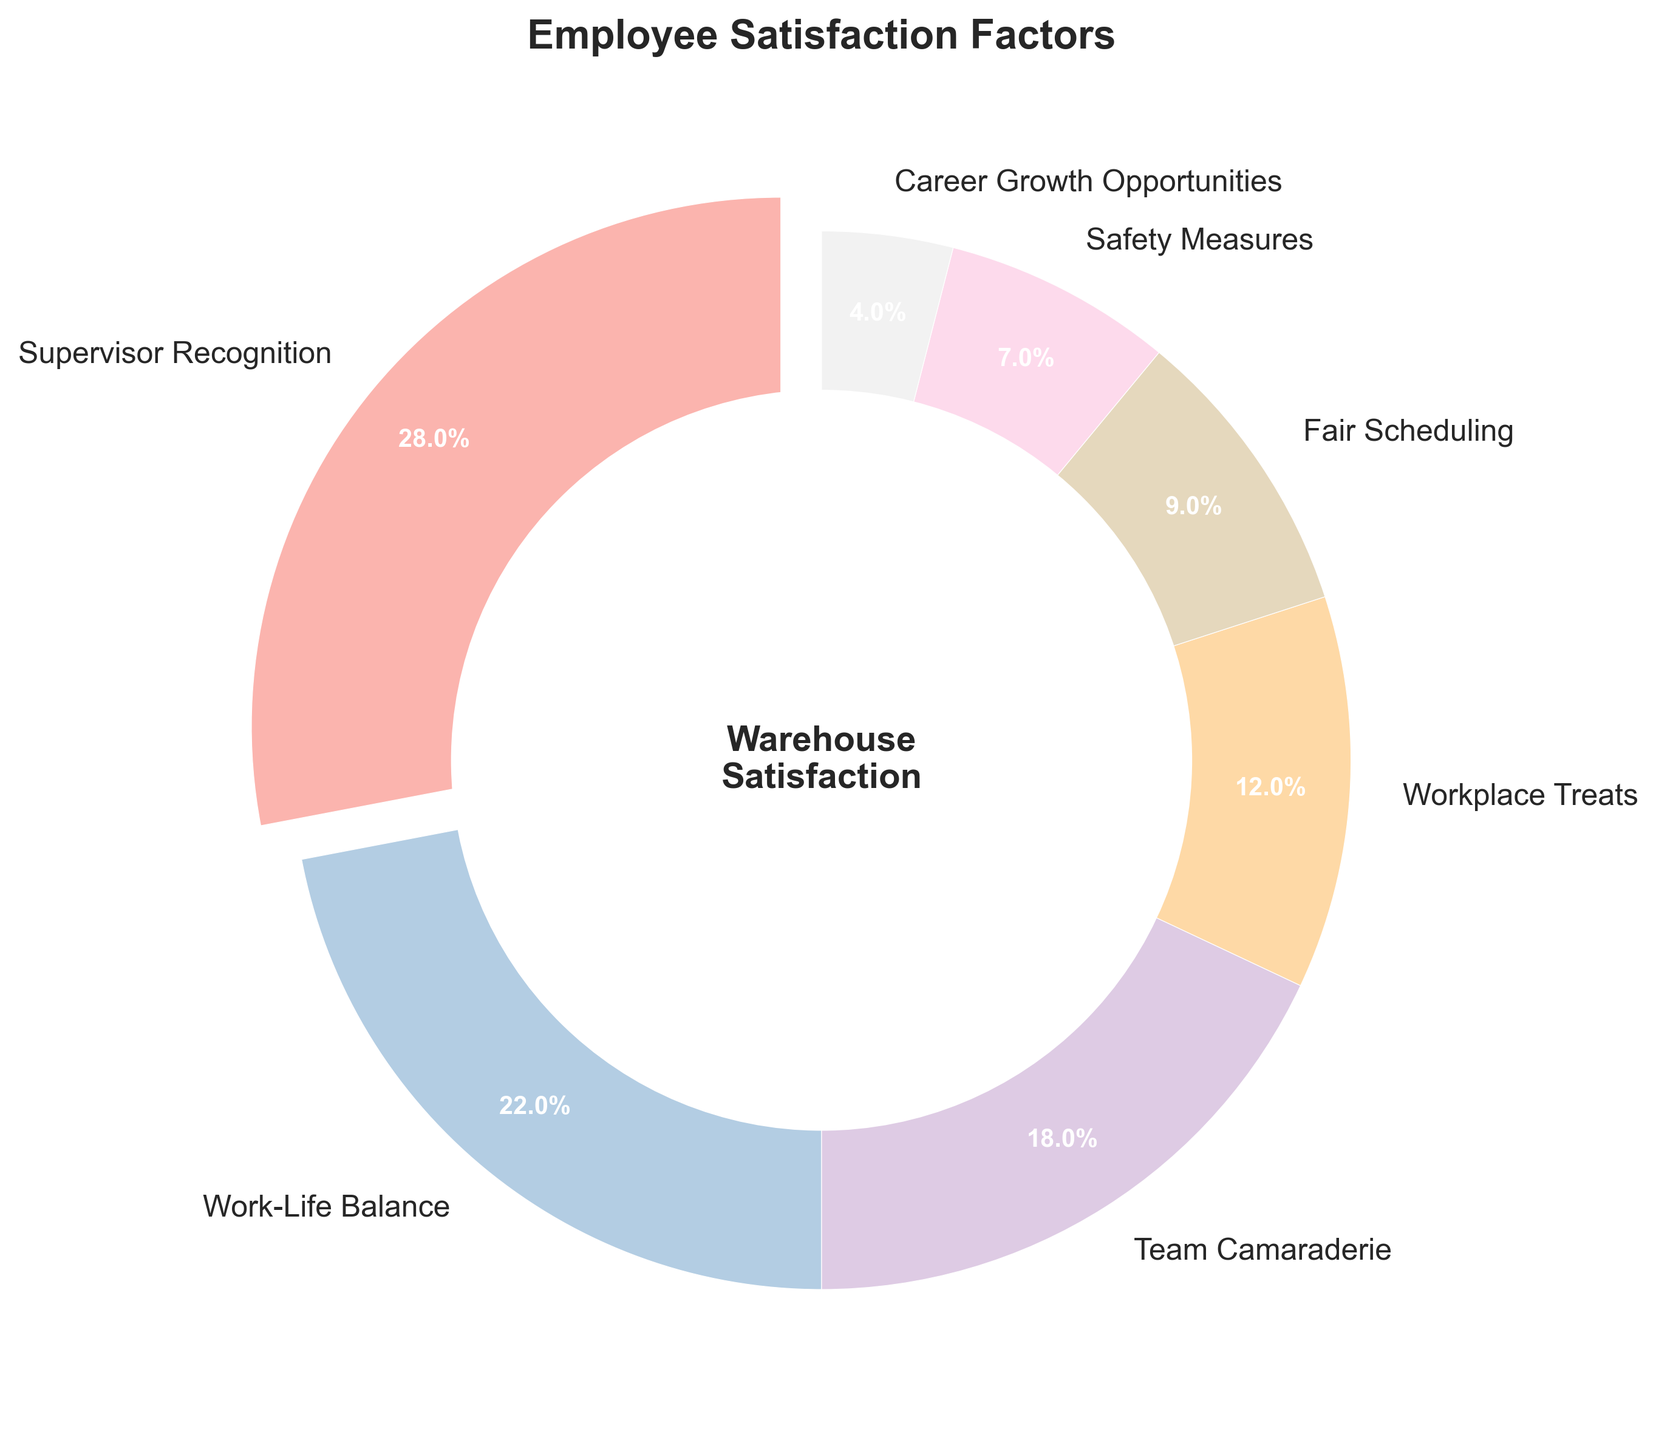Which factor contributes the most to employee satisfaction? The "Supervisor Recognition" segment has the largest size, indicating it has the highest percentage. The slice also has the largest label and is slightly separated from the rest of the plot.
Answer: Supervisor Recognition Which factor has the least impact on employee satisfaction? The "Career Growth Opportunities" segment is the smallest, representing the lowest percentage. It is visually the smallest slice in the pie chart.
Answer: Career Growth Opportunities How much higher is the percentage of people satisfied with "Supervisor Recognition" compared to "Work-Life Balance"? The percentage for "Supervisor Recognition" is 28%, while "Work-Life Balance" is 22%. The difference is calculated as 28% - 22%.
Answer: 6% Which two factors together make up half of the employee satisfaction? "Supervisor Recognition" and "Work-Life Balance" have percentages of 28% and 22%, respectively. Adding these together gives 28% + 22% = 50%.
Answer: Supervisor Recognition and Work-Life Balance What percentage of employees are satisfied with both "Team Camaraderie" and "Workplace Treats"? "Team Camaraderie" contributes 18% and "Workplace Treats" contributes 12%. Summing these gives 18% + 12% = 30%.
Answer: 30% Are there more employees satisfied with "Fair Scheduling" or "Safety Measures"? "Fair Scheduling" has a percentage of 9%, while "Safety Measures" has a percentage of 7%. 9% is greater than 7%.
Answer: Fair Scheduling Which factors have a combined satisfaction rate equal to the satisfaction rate of "Supervisor Recognition"? "Work-Life Balance" is 22% and "Career Growth Opportunities" is 4%. Adding these, 22% + 4% = 26%, which is slightly less. Instead, "Team Camaraderie" at 18% and "Workplace Treats" at 12% sum to 30%, which is closer but not exact. The closest pair without exceeding is "Work-Life Balance" + "Fair Scheduling" = 22% + 9% = 31%. Hence no exact match but the closest pair is noted.
Answer: No exact match How much lower is the satisfaction percentage of "Safety Measures" compared to "Workplace Treats"? The percentage for "Safety Measures" is 7%, and for "Workplace Treats" it is 12%. The difference is calculated as 12% - 7%.
Answer: 5% Which factor has a percentage closest to the median value of all factors? The percentages in ascending order are 4%, 7%, 9%, 12%, 18%, 22%, and 28%. The median value is the middle value, 12%.
Answer: Workplace Treats 